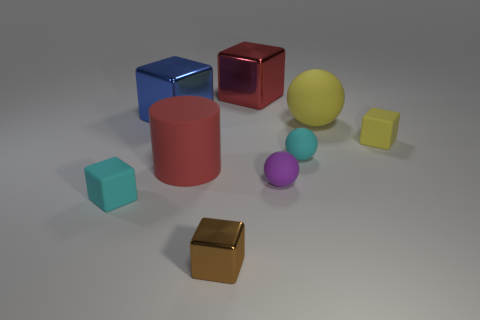Subtract all large matte balls. How many balls are left? 2 Subtract all spheres. How many objects are left? 6 Add 1 big yellow rubber spheres. How many objects exist? 10 Subtract all yellow blocks. How many blocks are left? 4 Subtract all yellow spheres. Subtract all cyan cylinders. How many spheres are left? 2 Subtract all red cylinders. How many cyan balls are left? 1 Subtract all tiny cyan rubber cubes. Subtract all large red shiny cubes. How many objects are left? 7 Add 7 metal cubes. How many metal cubes are left? 10 Add 1 small cyan matte blocks. How many small cyan matte blocks exist? 2 Subtract 0 gray cubes. How many objects are left? 9 